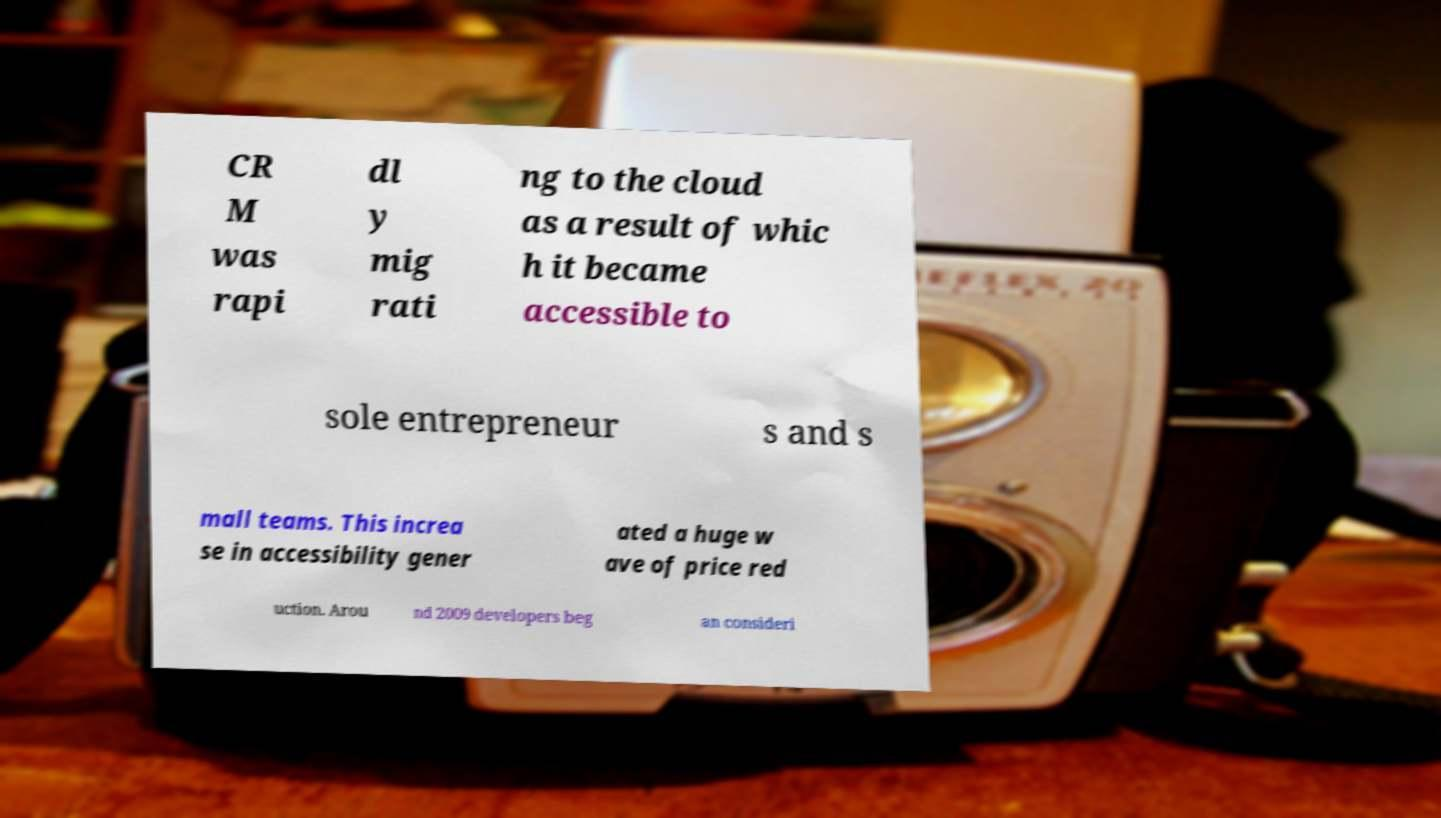Can you accurately transcribe the text from the provided image for me? CR M was rapi dl y mig rati ng to the cloud as a result of whic h it became accessible to sole entrepreneur s and s mall teams. This increa se in accessibility gener ated a huge w ave of price red uction. Arou nd 2009 developers beg an consideri 